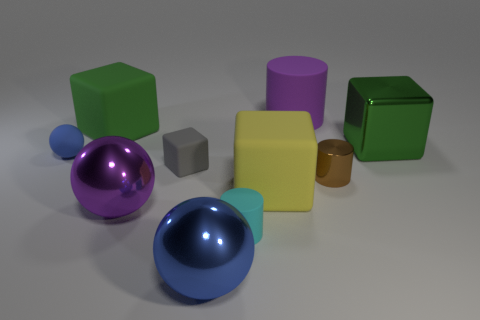Subtract all tiny matte blocks. How many blocks are left? 3 Subtract all yellow blocks. How many blocks are left? 3 Subtract 3 cubes. How many cubes are left? 1 Subtract all balls. How many objects are left? 7 Subtract all green cubes. How many cyan balls are left? 0 Add 1 small yellow cylinders. How many small yellow cylinders exist? 1 Subtract 0 cyan spheres. How many objects are left? 10 Subtract all blue balls. Subtract all cyan blocks. How many balls are left? 1 Subtract all purple shiny spheres. Subtract all cubes. How many objects are left? 5 Add 5 small brown metallic things. How many small brown metallic things are left? 6 